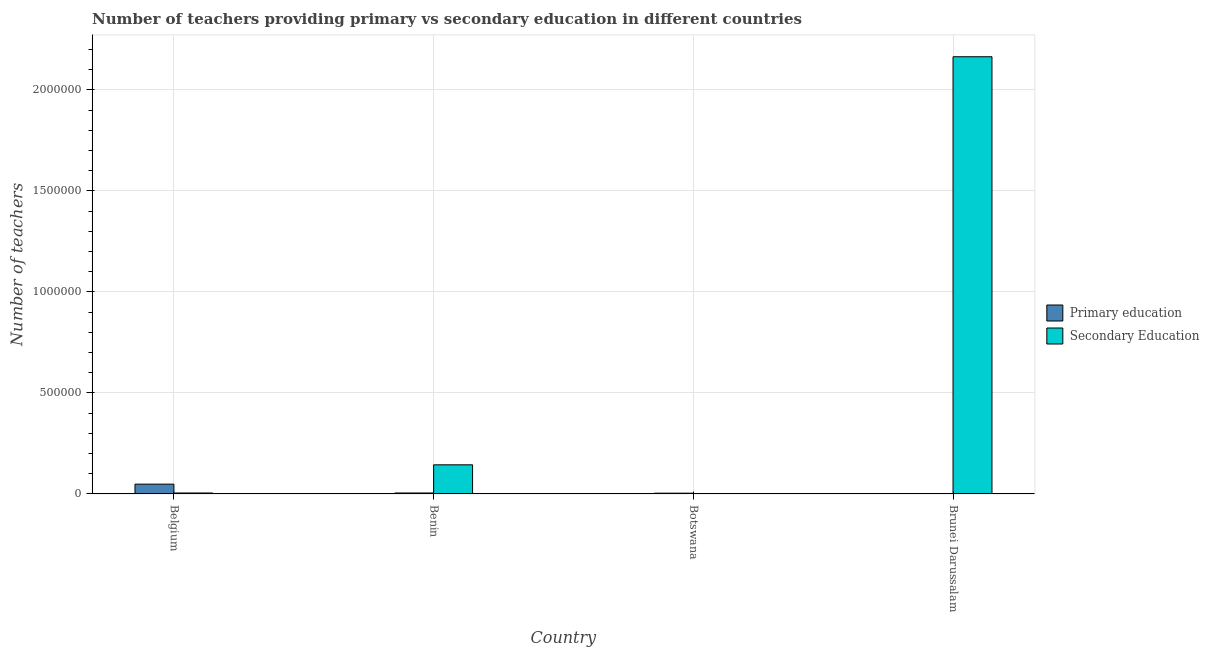How many different coloured bars are there?
Make the answer very short. 2. How many groups of bars are there?
Your response must be concise. 4. Are the number of bars on each tick of the X-axis equal?
Provide a short and direct response. Yes. How many bars are there on the 1st tick from the right?
Ensure brevity in your answer.  2. What is the label of the 2nd group of bars from the left?
Offer a very short reply. Benin. What is the number of primary teachers in Botswana?
Make the answer very short. 3921. Across all countries, what is the maximum number of primary teachers?
Keep it short and to the point. 4.86e+04. Across all countries, what is the minimum number of primary teachers?
Keep it short and to the point. 1679. In which country was the number of secondary teachers minimum?
Provide a succinct answer. Botswana. What is the total number of primary teachers in the graph?
Your answer should be very brief. 5.91e+04. What is the difference between the number of secondary teachers in Benin and that in Botswana?
Your response must be concise. 1.44e+05. What is the difference between the number of primary teachers in Botswana and the number of secondary teachers in Belgium?
Provide a succinct answer. -884. What is the average number of secondary teachers per country?
Your answer should be very brief. 5.78e+05. What is the difference between the number of primary teachers and number of secondary teachers in Belgium?
Make the answer very short. 4.38e+04. In how many countries, is the number of primary teachers greater than 1200000 ?
Ensure brevity in your answer.  0. What is the ratio of the number of secondary teachers in Benin to that in Botswana?
Provide a succinct answer. 1361.32. What is the difference between the highest and the second highest number of secondary teachers?
Your response must be concise. 2.02e+06. What is the difference between the highest and the lowest number of primary teachers?
Make the answer very short. 4.69e+04. In how many countries, is the number of secondary teachers greater than the average number of secondary teachers taken over all countries?
Keep it short and to the point. 1. Is the sum of the number of secondary teachers in Belgium and Brunei Darussalam greater than the maximum number of primary teachers across all countries?
Give a very brief answer. Yes. What does the 2nd bar from the left in Belgium represents?
Provide a short and direct response. Secondary Education. How many bars are there?
Your answer should be compact. 8. Where does the legend appear in the graph?
Provide a short and direct response. Center right. How many legend labels are there?
Give a very brief answer. 2. What is the title of the graph?
Your answer should be very brief. Number of teachers providing primary vs secondary education in different countries. Does "Primary" appear as one of the legend labels in the graph?
Make the answer very short. No. What is the label or title of the X-axis?
Your answer should be compact. Country. What is the label or title of the Y-axis?
Your answer should be compact. Number of teachers. What is the Number of teachers in Primary education in Belgium?
Ensure brevity in your answer.  4.86e+04. What is the Number of teachers in Secondary Education in Belgium?
Make the answer very short. 4805. What is the Number of teachers in Primary education in Benin?
Your answer should be compact. 4864. What is the Number of teachers of Secondary Education in Benin?
Provide a short and direct response. 1.44e+05. What is the Number of teachers of Primary education in Botswana?
Keep it short and to the point. 3921. What is the Number of teachers of Secondary Education in Botswana?
Keep it short and to the point. 106. What is the Number of teachers in Primary education in Brunei Darussalam?
Make the answer very short. 1679. What is the Number of teachers of Secondary Education in Brunei Darussalam?
Offer a very short reply. 2.16e+06. Across all countries, what is the maximum Number of teachers in Primary education?
Offer a terse response. 4.86e+04. Across all countries, what is the maximum Number of teachers of Secondary Education?
Ensure brevity in your answer.  2.16e+06. Across all countries, what is the minimum Number of teachers of Primary education?
Offer a very short reply. 1679. Across all countries, what is the minimum Number of teachers in Secondary Education?
Ensure brevity in your answer.  106. What is the total Number of teachers in Primary education in the graph?
Your answer should be compact. 5.91e+04. What is the total Number of teachers in Secondary Education in the graph?
Keep it short and to the point. 2.31e+06. What is the difference between the Number of teachers of Primary education in Belgium and that in Benin?
Give a very brief answer. 4.38e+04. What is the difference between the Number of teachers in Secondary Education in Belgium and that in Benin?
Provide a succinct answer. -1.39e+05. What is the difference between the Number of teachers of Primary education in Belgium and that in Botswana?
Provide a succinct answer. 4.47e+04. What is the difference between the Number of teachers in Secondary Education in Belgium and that in Botswana?
Make the answer very short. 4699. What is the difference between the Number of teachers in Primary education in Belgium and that in Brunei Darussalam?
Your answer should be compact. 4.69e+04. What is the difference between the Number of teachers in Secondary Education in Belgium and that in Brunei Darussalam?
Keep it short and to the point. -2.16e+06. What is the difference between the Number of teachers of Primary education in Benin and that in Botswana?
Give a very brief answer. 943. What is the difference between the Number of teachers of Secondary Education in Benin and that in Botswana?
Your response must be concise. 1.44e+05. What is the difference between the Number of teachers in Primary education in Benin and that in Brunei Darussalam?
Your response must be concise. 3185. What is the difference between the Number of teachers in Secondary Education in Benin and that in Brunei Darussalam?
Provide a short and direct response. -2.02e+06. What is the difference between the Number of teachers of Primary education in Botswana and that in Brunei Darussalam?
Provide a succinct answer. 2242. What is the difference between the Number of teachers in Secondary Education in Botswana and that in Brunei Darussalam?
Ensure brevity in your answer.  -2.16e+06. What is the difference between the Number of teachers of Primary education in Belgium and the Number of teachers of Secondary Education in Benin?
Offer a terse response. -9.57e+04. What is the difference between the Number of teachers of Primary education in Belgium and the Number of teachers of Secondary Education in Botswana?
Offer a very short reply. 4.85e+04. What is the difference between the Number of teachers in Primary education in Belgium and the Number of teachers in Secondary Education in Brunei Darussalam?
Offer a terse response. -2.12e+06. What is the difference between the Number of teachers in Primary education in Benin and the Number of teachers in Secondary Education in Botswana?
Your response must be concise. 4758. What is the difference between the Number of teachers in Primary education in Benin and the Number of teachers in Secondary Education in Brunei Darussalam?
Make the answer very short. -2.16e+06. What is the difference between the Number of teachers of Primary education in Botswana and the Number of teachers of Secondary Education in Brunei Darussalam?
Your response must be concise. -2.16e+06. What is the average Number of teachers of Primary education per country?
Your answer should be very brief. 1.48e+04. What is the average Number of teachers in Secondary Education per country?
Ensure brevity in your answer.  5.78e+05. What is the difference between the Number of teachers of Primary education and Number of teachers of Secondary Education in Belgium?
Offer a very short reply. 4.38e+04. What is the difference between the Number of teachers in Primary education and Number of teachers in Secondary Education in Benin?
Offer a terse response. -1.39e+05. What is the difference between the Number of teachers of Primary education and Number of teachers of Secondary Education in Botswana?
Offer a very short reply. 3815. What is the difference between the Number of teachers in Primary education and Number of teachers in Secondary Education in Brunei Darussalam?
Your answer should be compact. -2.16e+06. What is the ratio of the Number of teachers in Primary education in Belgium to that in Benin?
Your answer should be very brief. 10. What is the ratio of the Number of teachers in Primary education in Belgium to that in Botswana?
Offer a very short reply. 12.4. What is the ratio of the Number of teachers of Secondary Education in Belgium to that in Botswana?
Your answer should be compact. 45.33. What is the ratio of the Number of teachers of Primary education in Belgium to that in Brunei Darussalam?
Ensure brevity in your answer.  28.96. What is the ratio of the Number of teachers of Secondary Education in Belgium to that in Brunei Darussalam?
Give a very brief answer. 0. What is the ratio of the Number of teachers in Primary education in Benin to that in Botswana?
Your answer should be compact. 1.24. What is the ratio of the Number of teachers of Secondary Education in Benin to that in Botswana?
Provide a succinct answer. 1361.32. What is the ratio of the Number of teachers in Primary education in Benin to that in Brunei Darussalam?
Provide a succinct answer. 2.9. What is the ratio of the Number of teachers in Secondary Education in Benin to that in Brunei Darussalam?
Keep it short and to the point. 0.07. What is the ratio of the Number of teachers of Primary education in Botswana to that in Brunei Darussalam?
Keep it short and to the point. 2.34. What is the difference between the highest and the second highest Number of teachers in Primary education?
Provide a short and direct response. 4.38e+04. What is the difference between the highest and the second highest Number of teachers of Secondary Education?
Your answer should be compact. 2.02e+06. What is the difference between the highest and the lowest Number of teachers of Primary education?
Your answer should be very brief. 4.69e+04. What is the difference between the highest and the lowest Number of teachers of Secondary Education?
Offer a terse response. 2.16e+06. 